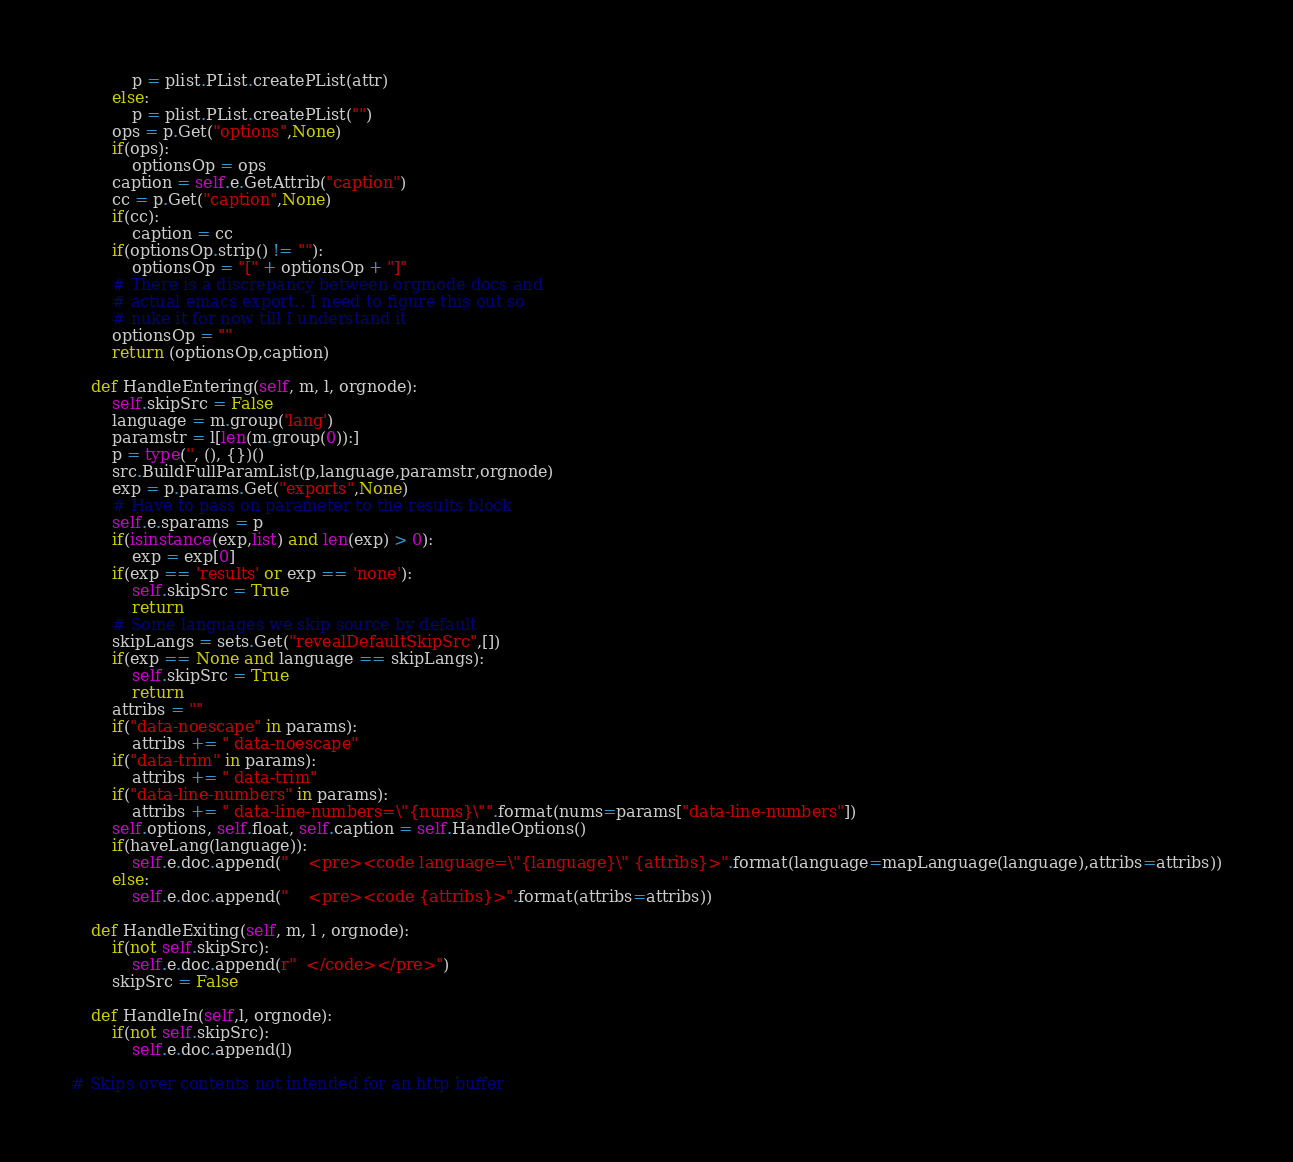<code> <loc_0><loc_0><loc_500><loc_500><_Python_>            p = plist.PList.createPList(attr)
        else:
            p = plist.PList.createPList("")
        ops = p.Get("options",None)
        if(ops):
            optionsOp = ops
        caption = self.e.GetAttrib("caption")
        cc = p.Get("caption",None)
        if(cc):
            caption = cc
        if(optionsOp.strip() != ""):
            optionsOp = "[" + optionsOp + "]"
        # There is a discrepancy between orgmode docs and
        # actual emacs export.. I need to figure this out so
        # nuke it for now till I understand it
        optionsOp = ""
        return (optionsOp,caption)

    def HandleEntering(self, m, l, orgnode):
        self.skipSrc = False
        language = m.group('lang')
        paramstr = l[len(m.group(0)):]
        p = type('', (), {})() 
        src.BuildFullParamList(p,language,paramstr,orgnode)
        exp = p.params.Get("exports",None)
        # Have to pass on parameter to the results block
        self.e.sparams = p
        if(isinstance(exp,list) and len(exp) > 0):
            exp = exp[0]
        if(exp == 'results' or exp == 'none'):
            self.skipSrc = True
            return
        # Some languages we skip source by default
        skipLangs = sets.Get("revealDefaultSkipSrc",[])
        if(exp == None and language == skipLangs):
            self.skipSrc = True
            return
        attribs = ""
        if("data-noescape" in params):
            attribs += " data-noescape"
        if("data-trim" in params):
            attribs += " data-trim"
        if("data-line-numbers" in params):
            attribs += " data-line-numbers=\"{nums}\"".format(nums=params["data-line-numbers"])
        self.options, self.float, self.caption = self.HandleOptions()
        if(haveLang(language)):
            self.e.doc.append("    <pre><code language=\"{language}\" {attribs}>".format(language=mapLanguage(language),attribs=attribs))
        else:
            self.e.doc.append("    <pre><code {attribs}>".format(attribs=attribs))

    def HandleExiting(self, m, l , orgnode):
        if(not self.skipSrc):
            self.e.doc.append(r"  </code></pre>")
        skipSrc = False

    def HandleIn(self,l, orgnode):
        if(not self.skipSrc):
            self.e.doc.append(l)

# Skips over contents not intended for an http buffer</code> 